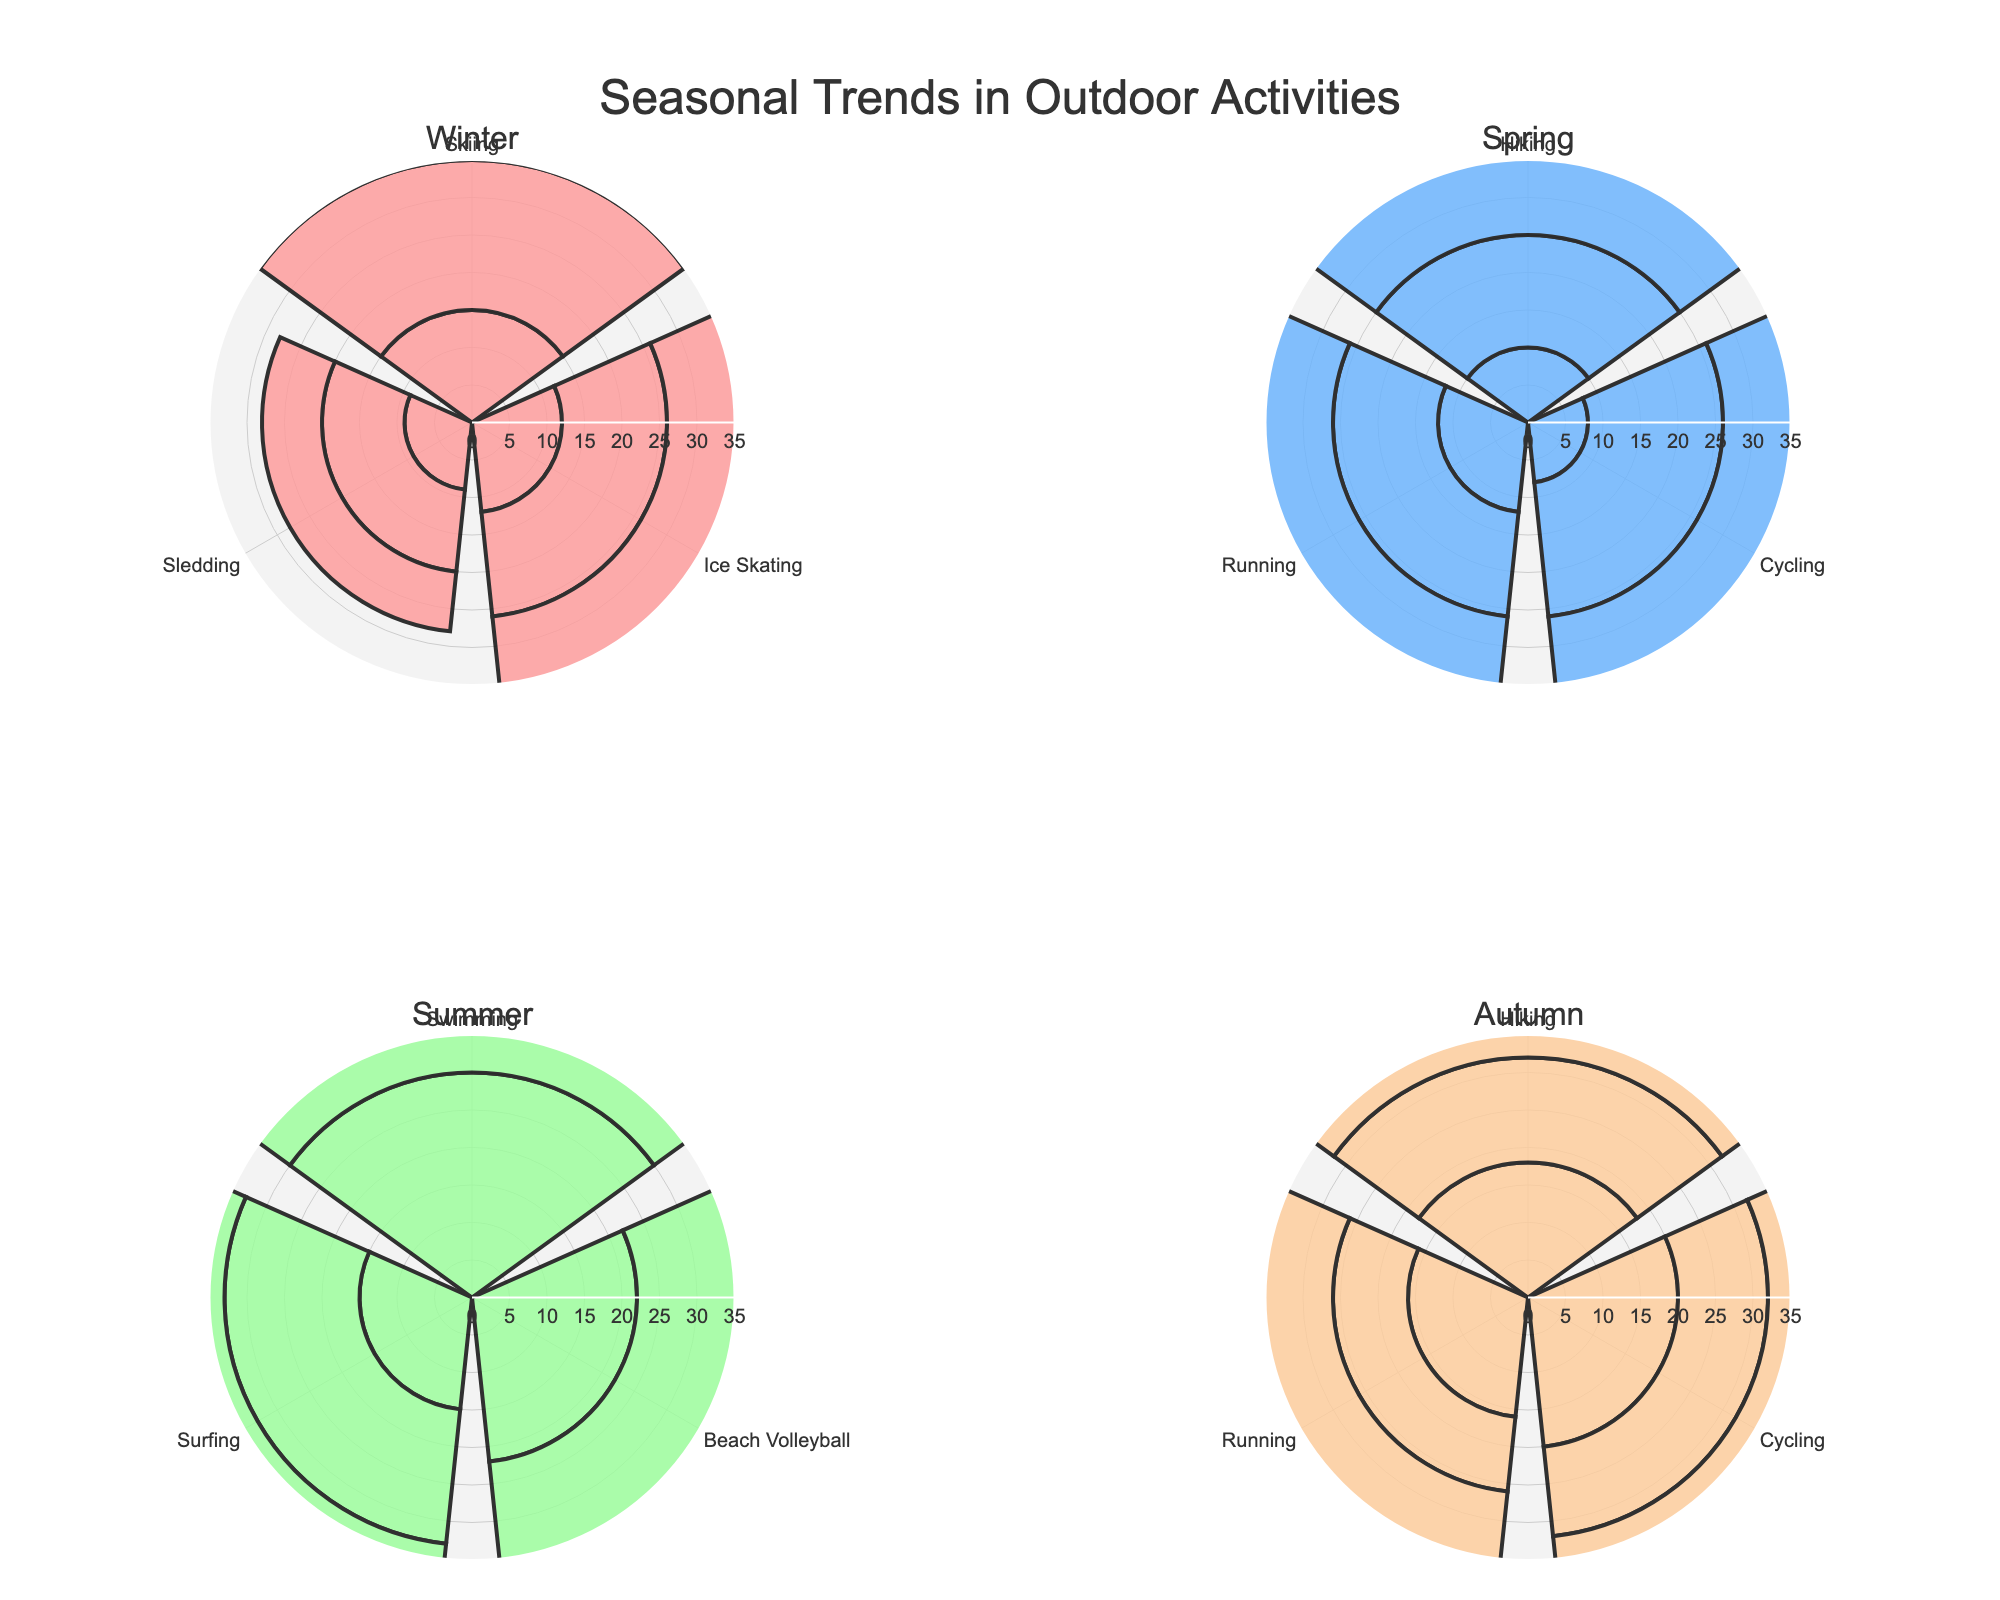Which season has the highest frequency for Swimming? In the Summer subplot, there are bars representing Swimming in June, July, and August. By observing the lengths of the bars, you'll see that July has the highest frequency for Swimming.
Answer: July Which activity appears in all four seasons? In each of the four subplots (Winter, Spring, Summer, Autumn), check the activities listed in each segment. Hiking, Running, and Cycling appear in all four seasons.
Answer: Hiking, Running, and Cycling What is the total frequency of Ice Skating in Winter? In the Winter subplot, add the frequencies of Ice Skating activities for December, January, and February: 10 (December) + 12 (January) + 14 (February).
Answer: 36 Which activity has the highest frequency in Spring? In the Spring subplot, compare the frequencies of Hiking, Cycling, and Running. Cycling has the highest frequency in May, which is the highest among all Spring activities.
Answer: Cycling How does the frequency of Beach Volleyball in Summer compare to Autumn? In the Summer subplot, the frequencies of Beach Volleyball are: June 22, July 25, August 24. In the Autumn subplot, Beach Volleyball is not listed.
Answer: Summer has higher frequency What is the frequency range for Surfing in Summer? In the Summer subplot, the frequencies for Surfing are 15 (June), 18 (July), and 17 (August). Find the range by subtracting the smallest frequency from the largest: 18 - 15.
Answer: 3 Which season has the most varied types of activities? In each season subplot, count the different types of activities. Winter has Skiing, Ice Skating, and Sledding (3). Spring has Hiking, Cycling, and Running (3). Summer has Swimming, Beach Volleyball, and Surfing (3). Autumn has Hiking, Cycling, and Running (3). All four seasons have three types of activities each.
Answer: All seasons equally varied What is the average frequency of Hiking in Autumn? In the Autumn subplot, the frequencies for Hiking are 18 (September), 14 (October), and 10 (November). Sum these values and divide by the number of months: (18 + 14 + 10) / 3.
Answer: 14 Which activity in Winter has the lowest total frequency? In the Winter subplot, compare the total frequencies of all Winter activities by summing their individual monthly frequencies. Sledding: 9 (January) + 11 (February) + 8 (December) = 28. Ice Skating: 12 (January) + 14 (February) + 10 (December) = 36. Skiing: 15 (January) + 20 (February) + 12 (December) = 47. Sledding has the lowest total frequency.
Answer: Sledding 